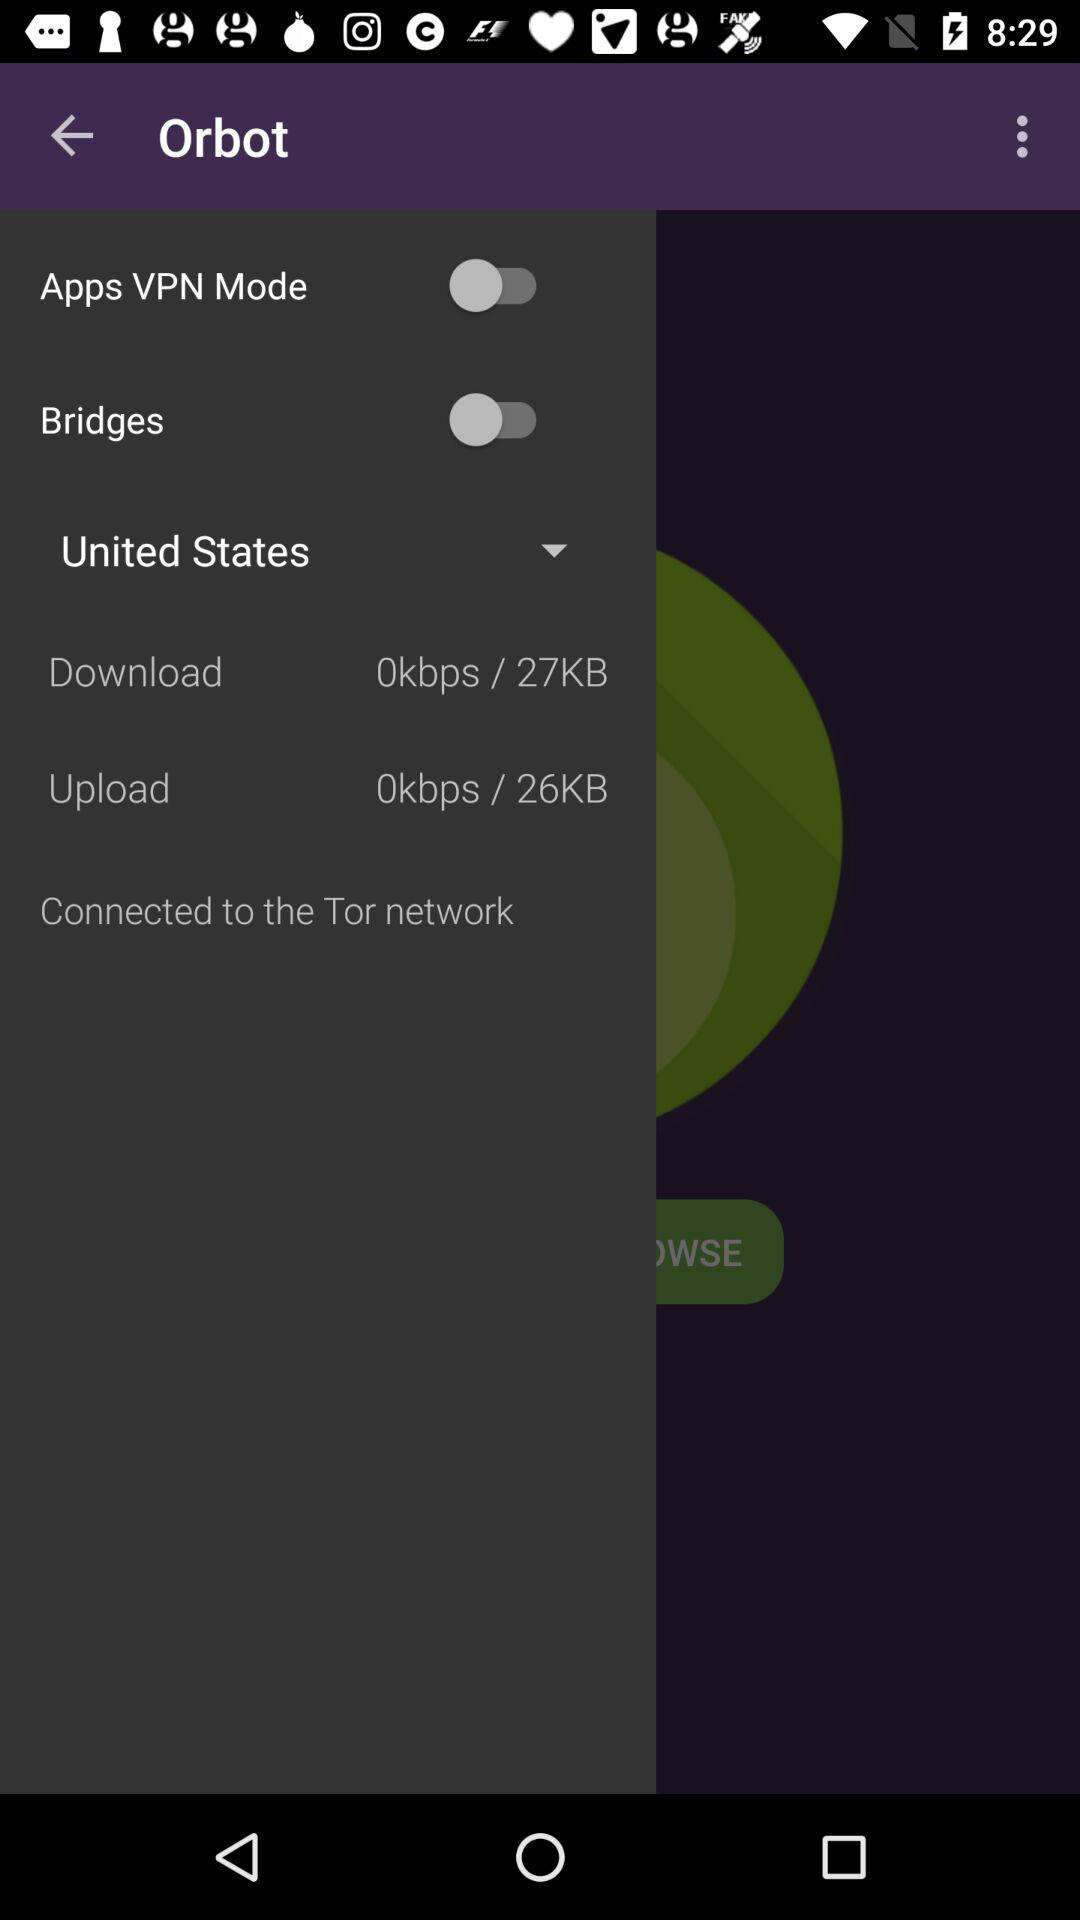What is the status of "Apps VPN Mode"? The status of "Apps VPN Mode" is "off". 